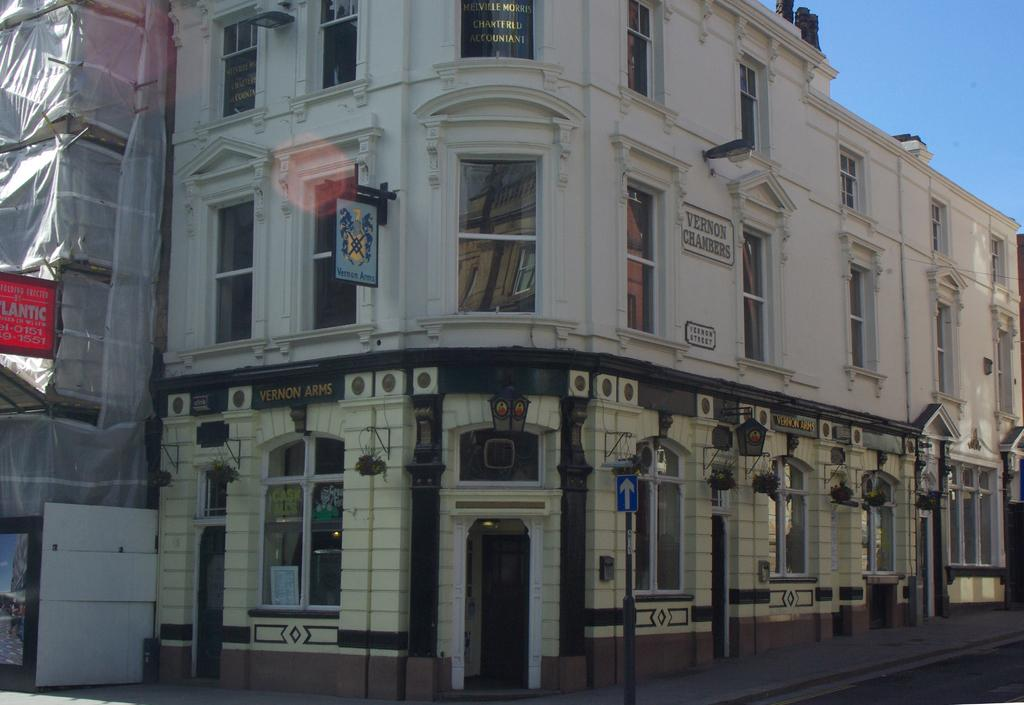What type of structures can be seen in the image? There are buildings in the image. What architectural features are visible on the buildings? There are windows and a door visible on the buildings. What additional objects can be seen in the image? There are boards and a cover present in the image. How would you describe the weather based on the image? The sky is sunny in the image. How many snakes are crawling on the buildings in the image? There are no snakes present in the image; it features buildings with windows, a door, boards, and a cover. 